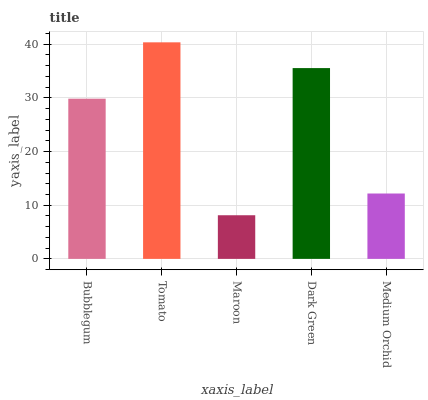Is Maroon the minimum?
Answer yes or no. Yes. Is Tomato the maximum?
Answer yes or no. Yes. Is Tomato the minimum?
Answer yes or no. No. Is Maroon the maximum?
Answer yes or no. No. Is Tomato greater than Maroon?
Answer yes or no. Yes. Is Maroon less than Tomato?
Answer yes or no. Yes. Is Maroon greater than Tomato?
Answer yes or no. No. Is Tomato less than Maroon?
Answer yes or no. No. Is Bubblegum the high median?
Answer yes or no. Yes. Is Bubblegum the low median?
Answer yes or no. Yes. Is Medium Orchid the high median?
Answer yes or no. No. Is Dark Green the low median?
Answer yes or no. No. 